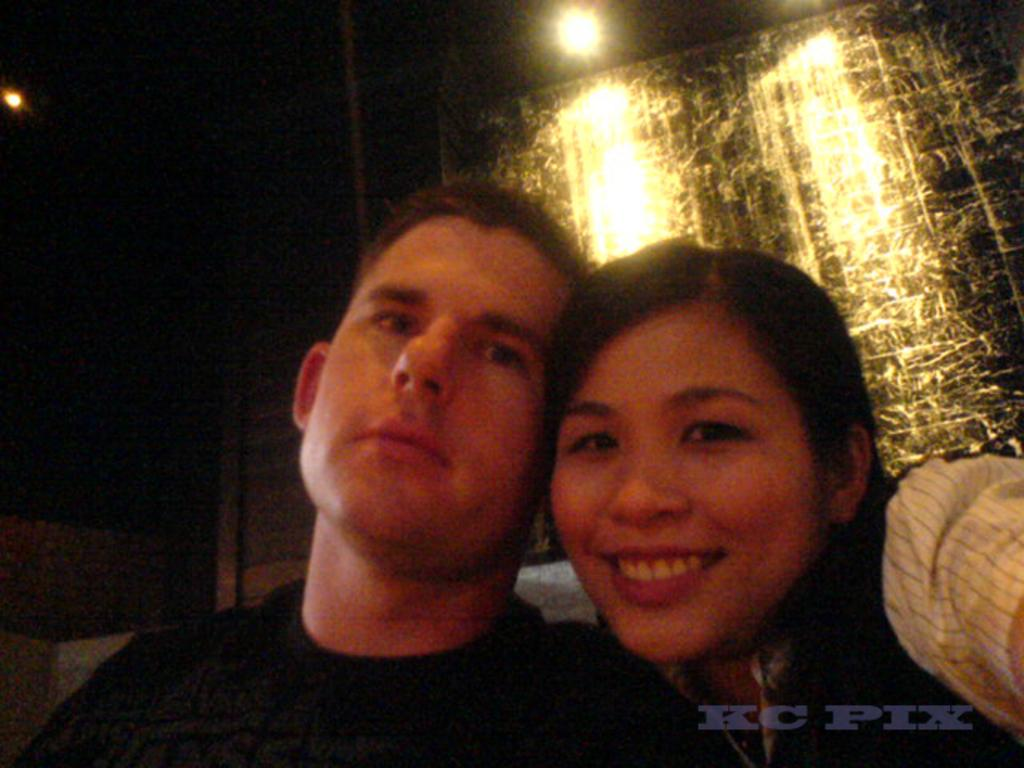How many people are in the image? There are two persons in the image. What are the two persons doing in the image? The two persons are looking at the camera. Can you describe anything about the hand of another person in the image? Yes, there is a hand of another person beside the two persons. What is the color of the background in the image? The background of the image is dark. What type of attraction can be seen in the background of the image? There is no attraction visible in the background of the image; it is dark. What level of difficulty is the cook facing in the image? There is no cook present in the image, so it is not possible to determine the level of difficulty they might be facing. 